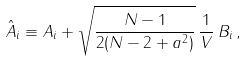Convert formula to latex. <formula><loc_0><loc_0><loc_500><loc_500>\hat { A } _ { i } \equiv A _ { i } + \sqrt { \frac { N - 1 } { 2 ( N - 2 + a ^ { 2 } ) } } \, \frac { 1 } { V } \, B _ { i } \, ,</formula> 